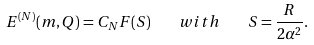Convert formula to latex. <formula><loc_0><loc_0><loc_500><loc_500>E ^ { ( N ) } ( m , Q ) = C _ { N } F ( S ) \quad w i t h \quad S = \frac { R } { 2 \alpha ^ { 2 } } .</formula> 